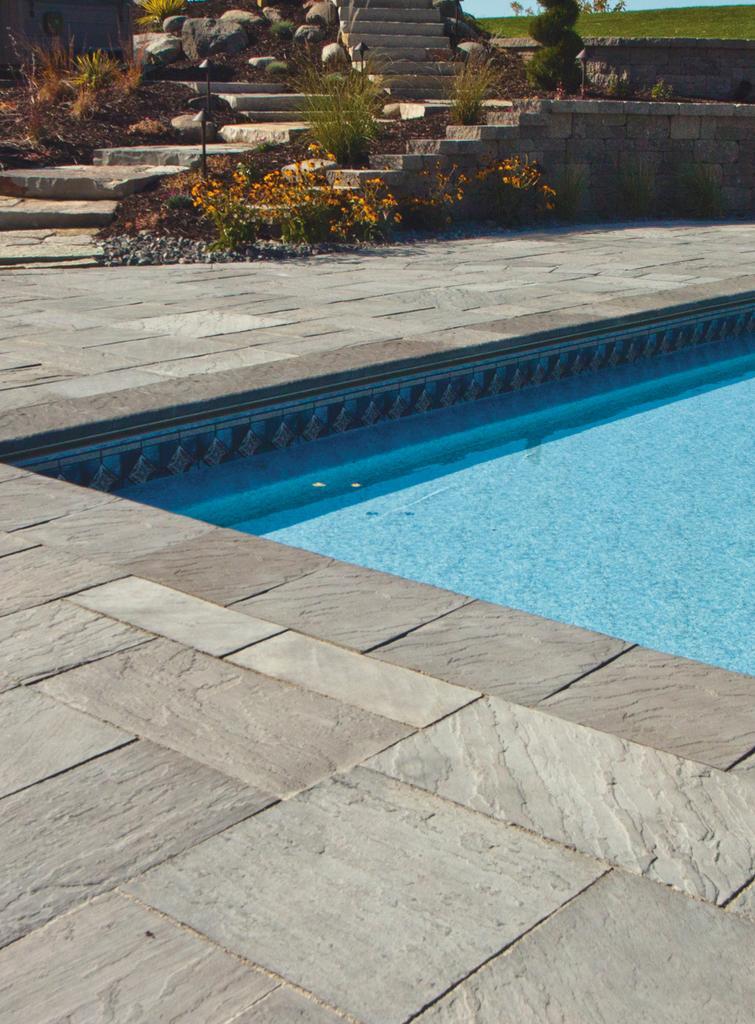Please provide a concise description of this image. At the top of the image we can see the stairs, rocks, plants, flowers, wall, trees, sky. In the center of the image we can see a pool which contains water. At the bottom of the image we can see the floor. 